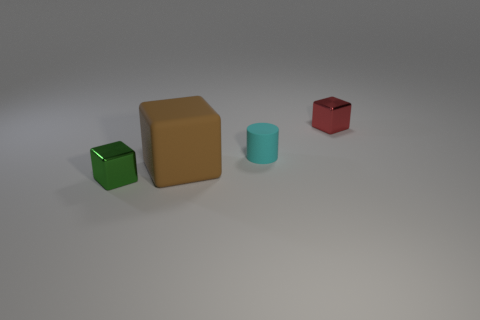Subtract all small shiny cubes. How many cubes are left? 1 Add 4 small blue cubes. How many small blue cubes exist? 4 Add 2 large blue matte blocks. How many objects exist? 6 Subtract all red blocks. How many blocks are left? 2 Subtract 0 blue balls. How many objects are left? 4 Subtract all cylinders. How many objects are left? 3 Subtract 1 cylinders. How many cylinders are left? 0 Subtract all yellow cylinders. Subtract all red balls. How many cylinders are left? 1 Subtract all brown cylinders. How many green cubes are left? 1 Subtract all small red shiny cubes. Subtract all tiny purple rubber blocks. How many objects are left? 3 